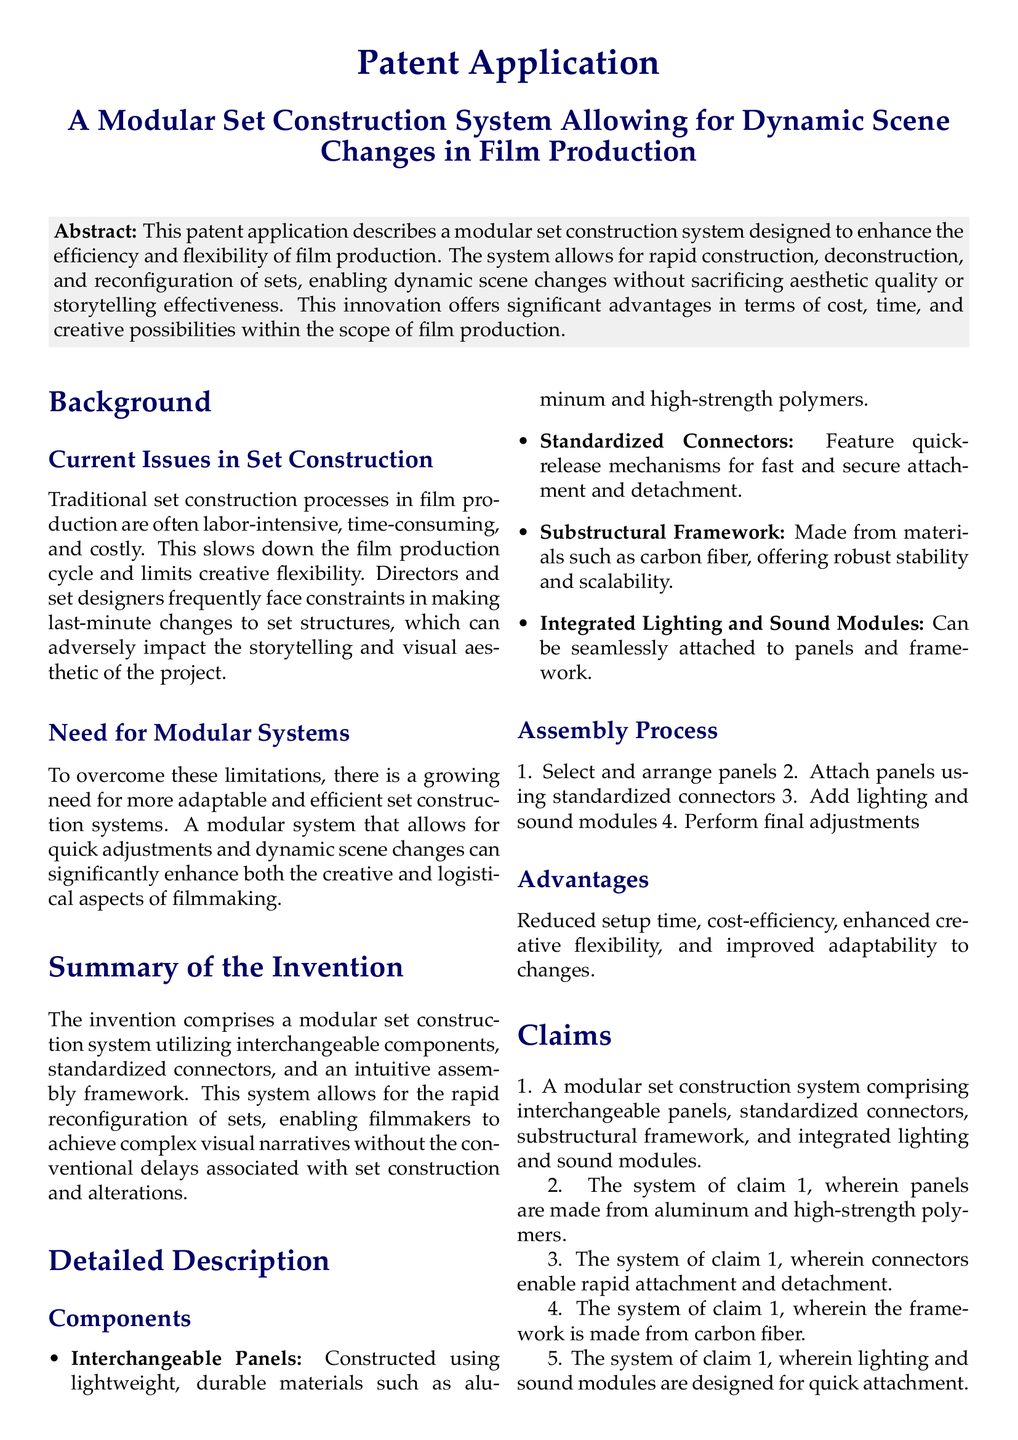What is the title of the patent application? The title of the patent application is specifically stated in the document.
Answer: A Modular Set Construction System Allowing for Dynamic Scene Changes in Film Production What materials are the interchangeable panels made from? The document states that panels are constructed using specific materials.
Answer: Aluminum and high-strength polymers What feature allows for rapid attachment and detachment of the connectors? The document discusses a mechanism that emphasizes speed in assembly.
Answer: Quick-release mechanisms What is the primary advantage of the proposed modular system? The document outlines key benefits that enhance film production.
Answer: Enhanced creative flexibility What type of framework is used in the system? The document specifies the material used for the framework, highlighting its properties.
Answer: Carbon fiber How many steps are in the assembly process? The assembly process is listed and enumerated in the document.
Answer: Four What are the integrated modules designed for? The document identifies the functionality of specific components attached to the set.
Answer: Lighting and sound What does the patent application aim to improve? The document identifies the main focus of the invention.
Answer: Efficiency and flexibility of film production 